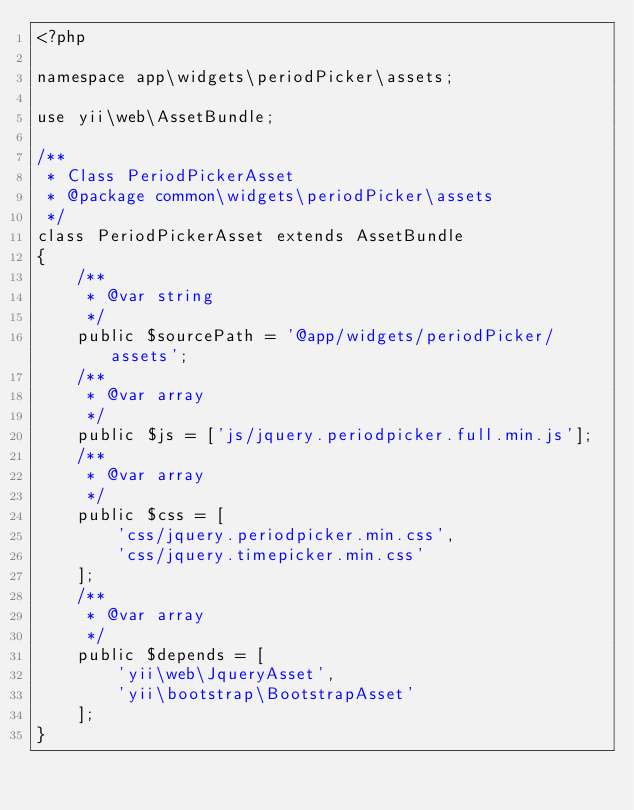Convert code to text. <code><loc_0><loc_0><loc_500><loc_500><_PHP_><?php

namespace app\widgets\periodPicker\assets;

use yii\web\AssetBundle;

/**
 * Class PeriodPickerAsset
 * @package common\widgets\periodPicker\assets
 */
class PeriodPickerAsset extends AssetBundle
{
    /**
     * @var string
     */
    public $sourcePath = '@app/widgets/periodPicker/assets';
    /**
     * @var array
     */
    public $js = ['js/jquery.periodpicker.full.min.js'];
    /**
     * @var array
     */
    public $css = [
        'css/jquery.periodpicker.min.css',
        'css/jquery.timepicker.min.css'
    ];
    /**
     * @var array
     */
    public $depends = [
        'yii\web\JqueryAsset',
        'yii\bootstrap\BootstrapAsset'
    ];
}
</code> 